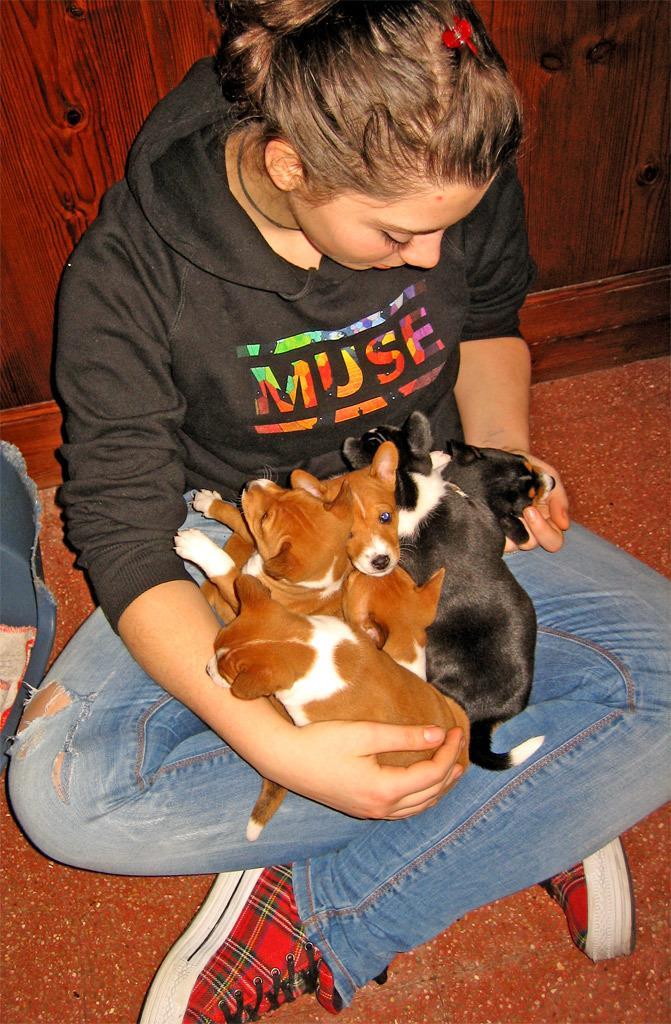Describe this image in one or two sentences. In this image we can see a woman sitting on the floor holding some dogs. We can also see an object beside her. On the backside we can see a wall. 